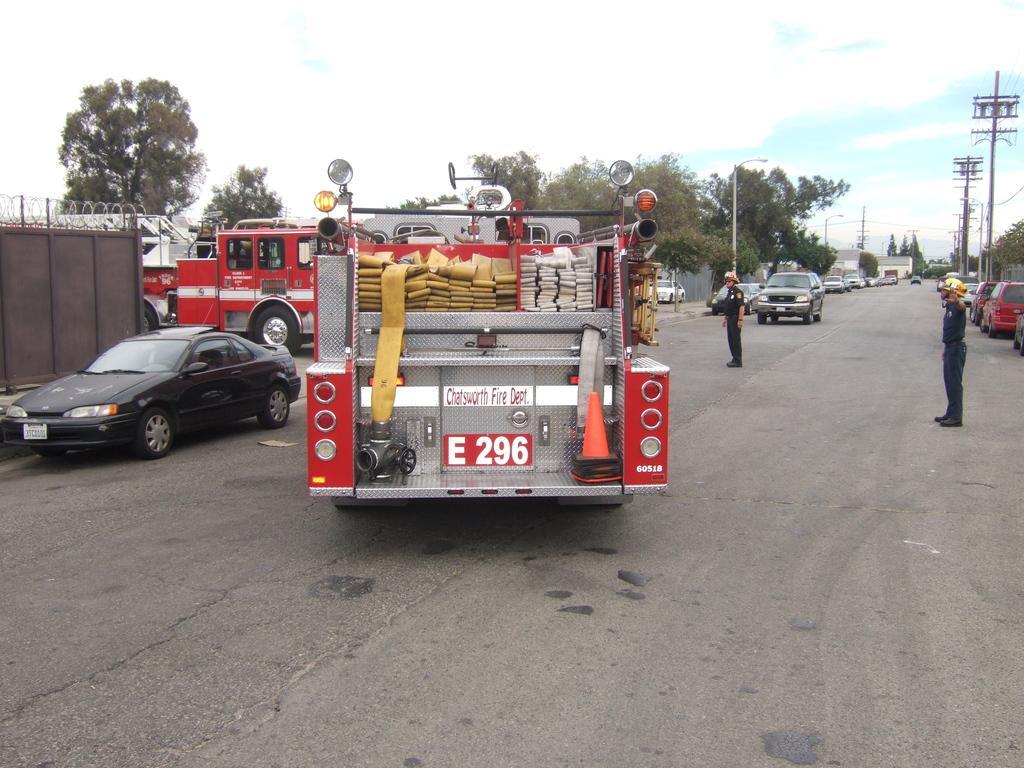In one or two sentences, can you explain what this image depicts? In this image we can see there are few vehicles and two persons are on the road. On the left side there is a fencing. In the background there are trees, utility poles and sky. 